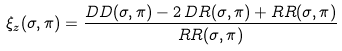<formula> <loc_0><loc_0><loc_500><loc_500>\xi _ { z } ( \sigma , \pi ) = \frac { D D ( \sigma , \pi ) - 2 \, D R ( \sigma , \pi ) + R R ( \sigma , \pi ) } { R R ( \sigma , \pi ) }</formula> 